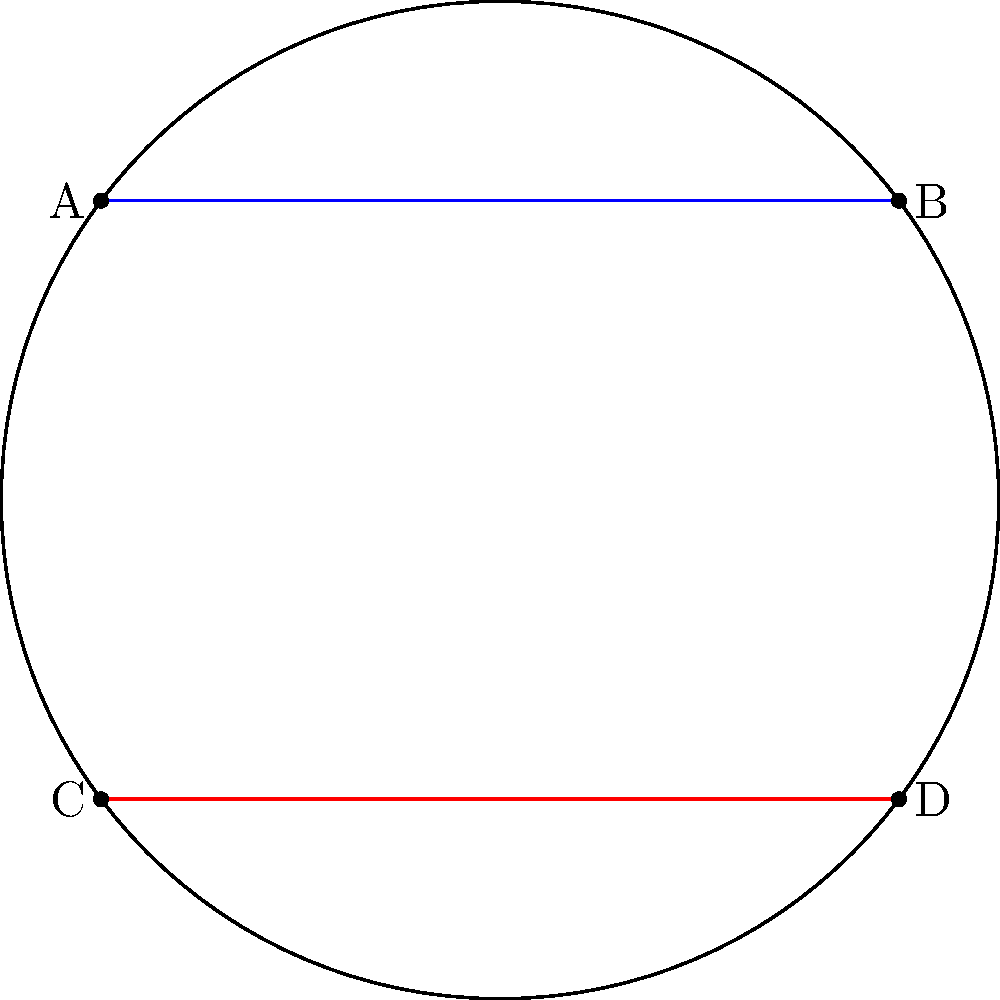In the context of Non-Euclidean Geometry, consider two musical staff lines (blue and red) drawn on the surface of a sphere, as shown in the diagram. These lines represent parallel lines in spherical geometry. If we extend these lines, what will happen to the distance between them, and how does this relate to the concept of parallel lines in Euclidean geometry? To understand this concept, let's break it down step-by-step:

1. In Euclidean geometry (flat surfaces), parallel lines maintain a constant distance and never intersect.

2. However, on a sphere (non-Euclidean geometry), the concept of "parallel" is different:
   a. Great circles on a sphere are analogous to straight lines in Euclidean geometry.
   b. Two great circles always intersect at two antipodal points.

3. In our diagram:
   a. The blue line (AB) and red line (CD) represent two "parallel" lines on the sphere.
   b. These lines are actually segments of great circles.

4. As we extend these lines:
   a. They will continue along their respective great circles.
   b. Eventually, they will intersect at two points (not shown in the diagram).

5. The distance between these lines:
   a. Starts decreasing as we move away from the equator.
   b. Becomes zero at the points of intersection.

6. This behavior is similar to how musical notes on a staff can appear to converge or diverge depending on the musical progression, even though they maintain their relative positions.

7. The key difference from Euclidean geometry:
   a. In Euclidean geometry, parallel lines maintain a constant distance and never intersect.
   b. In spherical geometry, "parallel" lines (great circles) always intersect.

This concept demonstrates that the familiar properties of parallel lines in Euclidean geometry do not hold in non-Euclidean geometries, such as on the surface of a sphere.
Answer: The lines will converge and intersect at two antipodal points, unlike parallel lines in Euclidean geometry. 